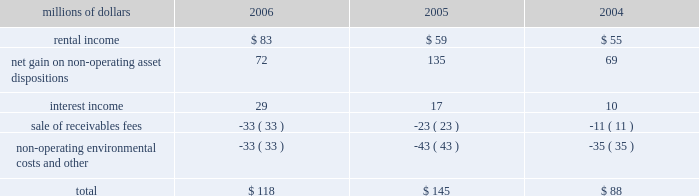The environmental liability includes costs for remediation and restoration of sites , as well as for ongoing monitoring costs , but excludes any anticipated recoveries from third parties .
Cost estimates are based on information available for each site , financial viability of other potentially responsible parties , and existing technology , laws , and regulations .
We believe that we have adequately accrued for our ultimate share of costs at sites subject to joint and several liability .
However , the ultimate liability for remediation is difficult to determine because of the number of potentially responsible parties involved , site-specific cost sharing arrangements with other potentially responsible parties , the degree of contamination by various wastes , the scarcity and quality of volumetric data related to many of the sites , and the speculative nature of remediation costs .
Estimates may also vary due to changes in federal , state , and local laws governing environmental remediation .
We do not expect current obligations to have a material adverse effect on our results of operations or financial condition .
Guarantees 2013 at december 31 , 2006 , we were contingently liable for $ 464 million in guarantees .
We have recorded a liability of $ 6 million for the fair value of these obligations as of december 31 , 2006 .
We entered into these contingent guarantees in the normal course of business , and they include guaranteed obligations related to our headquarters building , equipment financings , and affiliated operations .
The final guarantee expires in 2022 .
We are not aware of any existing event of default that would require us to satisfy these guarantees .
We do not expect that these guarantees will have a material adverse effect on our consolidated financial condition , results of operations , or liquidity .
Indemnities 2013 our maximum potential exposure under indemnification arrangements , including certain tax indemnifications , can range from a specified dollar amount to an unlimited amount , depending on the nature of the transactions and the agreements .
Due to uncertainty as to whether claims will be made or how they will be resolved , we cannot reasonably determine the probability of an adverse claim or reasonably estimate any adverse liability or the total maximum exposure under these indemnification arrangements .
We do not have any reason to believe that we will be required to make any material payments under these indemnity provisions .
Income taxes 2013 as previously reported in our form 10-q for the quarter ended september 30 , 2005 , the irs has completed its examinations and issued notices of deficiency for tax years 1995 through 2002 .
Among their proposed adjustments is the disallowance of tax deductions claimed in connection with certain donations of property .
In the fourth quarter of 2005 , the irs national office issued a technical advice memorandum which left unresolved whether the deductions were proper , pending further factual development .
We continue to dispute the donation issue , as well as many of the other proposed adjustments , and will contest the associated tax deficiencies through the irs appeals process , and , if necessary , litigation .
In addition , the irs is examining the corporation 2019s federal income tax returns for tax years 2003 and 2004 and should complete their exam in 2007 .
We do not expect that the ultimate resolution of these examinations will have a material adverse effect on our consolidated financial statements .
11 .
Other income other income included the following for the years ended december 31 : millions of dollars 2006 2005 2004 .

What was the percentage change in rental income from 2004 to 2005? 
Computations: ((59 - 55) / 55)
Answer: 0.07273. 